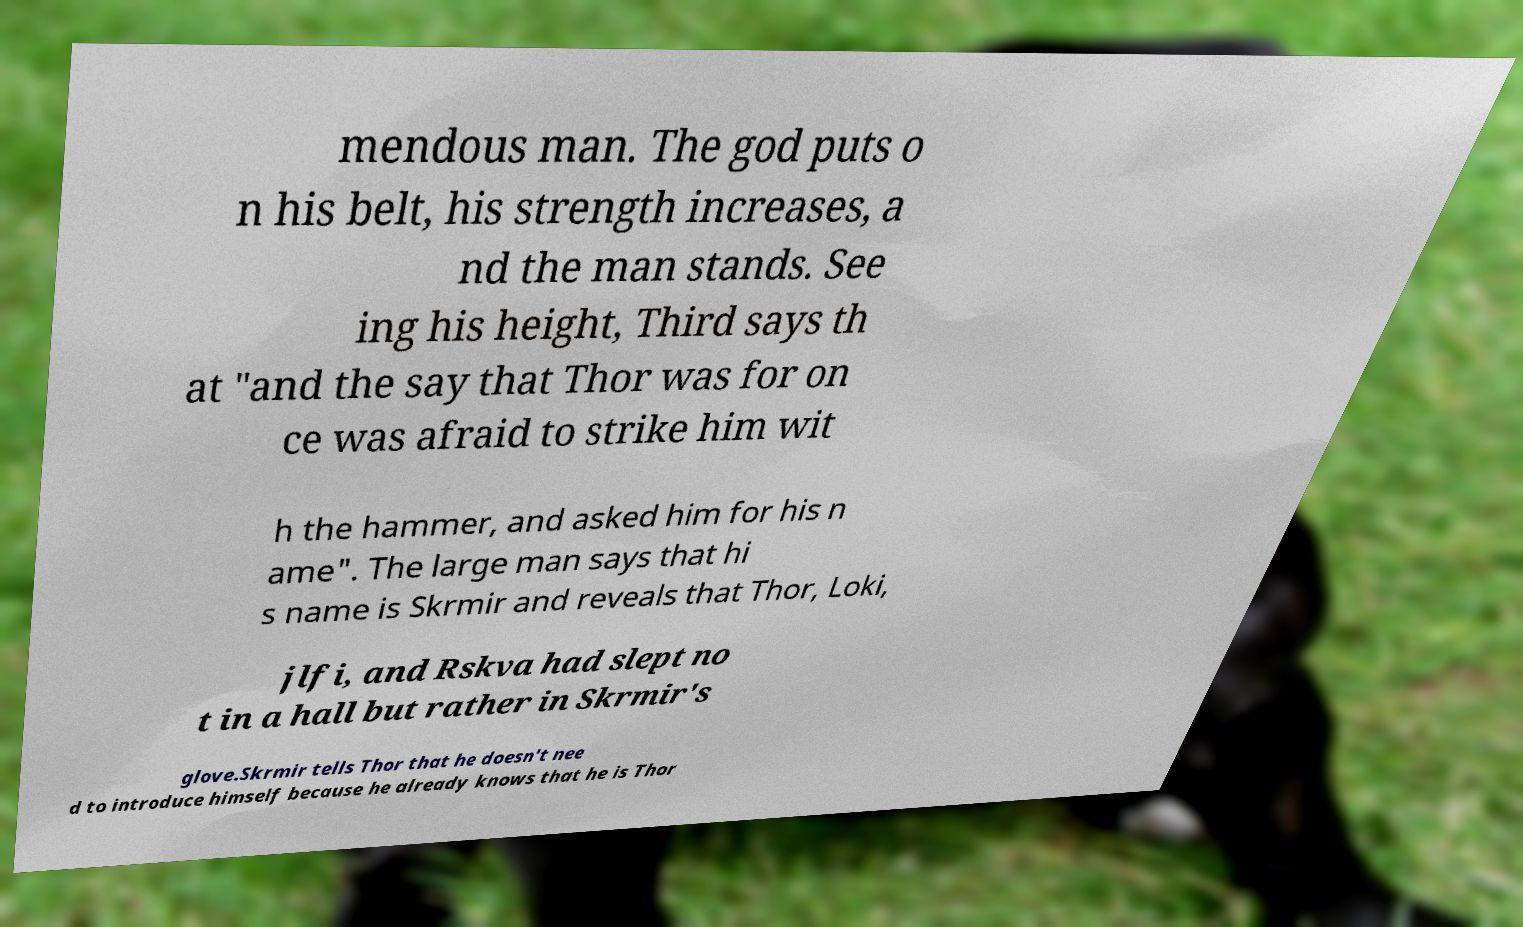There's text embedded in this image that I need extracted. Can you transcribe it verbatim? mendous man. The god puts o n his belt, his strength increases, a nd the man stands. See ing his height, Third says th at "and the say that Thor was for on ce was afraid to strike him wit h the hammer, and asked him for his n ame". The large man says that hi s name is Skrmir and reveals that Thor, Loki, jlfi, and Rskva had slept no t in a hall but rather in Skrmir's glove.Skrmir tells Thor that he doesn't nee d to introduce himself because he already knows that he is Thor 